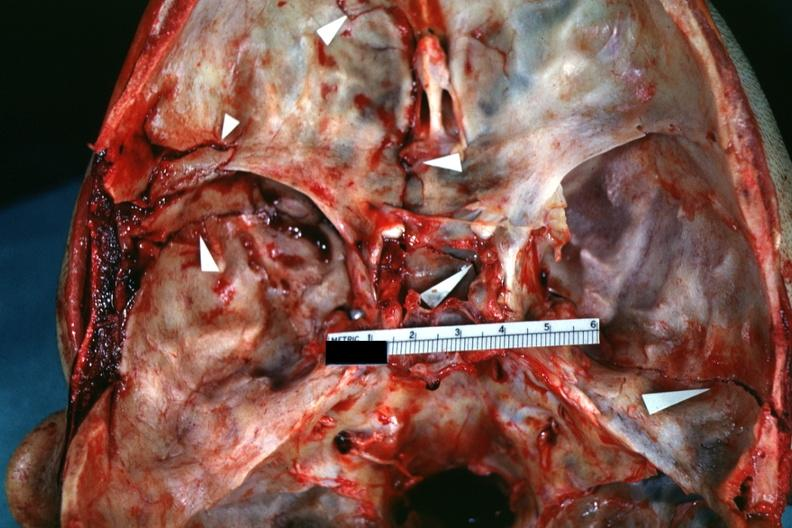s bone, calvarium present?
Answer the question using a single word or phrase. Yes 